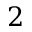Convert formula to latex. <formula><loc_0><loc_0><loc_500><loc_500>2</formula> 